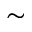Convert formula to latex. <formula><loc_0><loc_0><loc_500><loc_500>\sim</formula> 